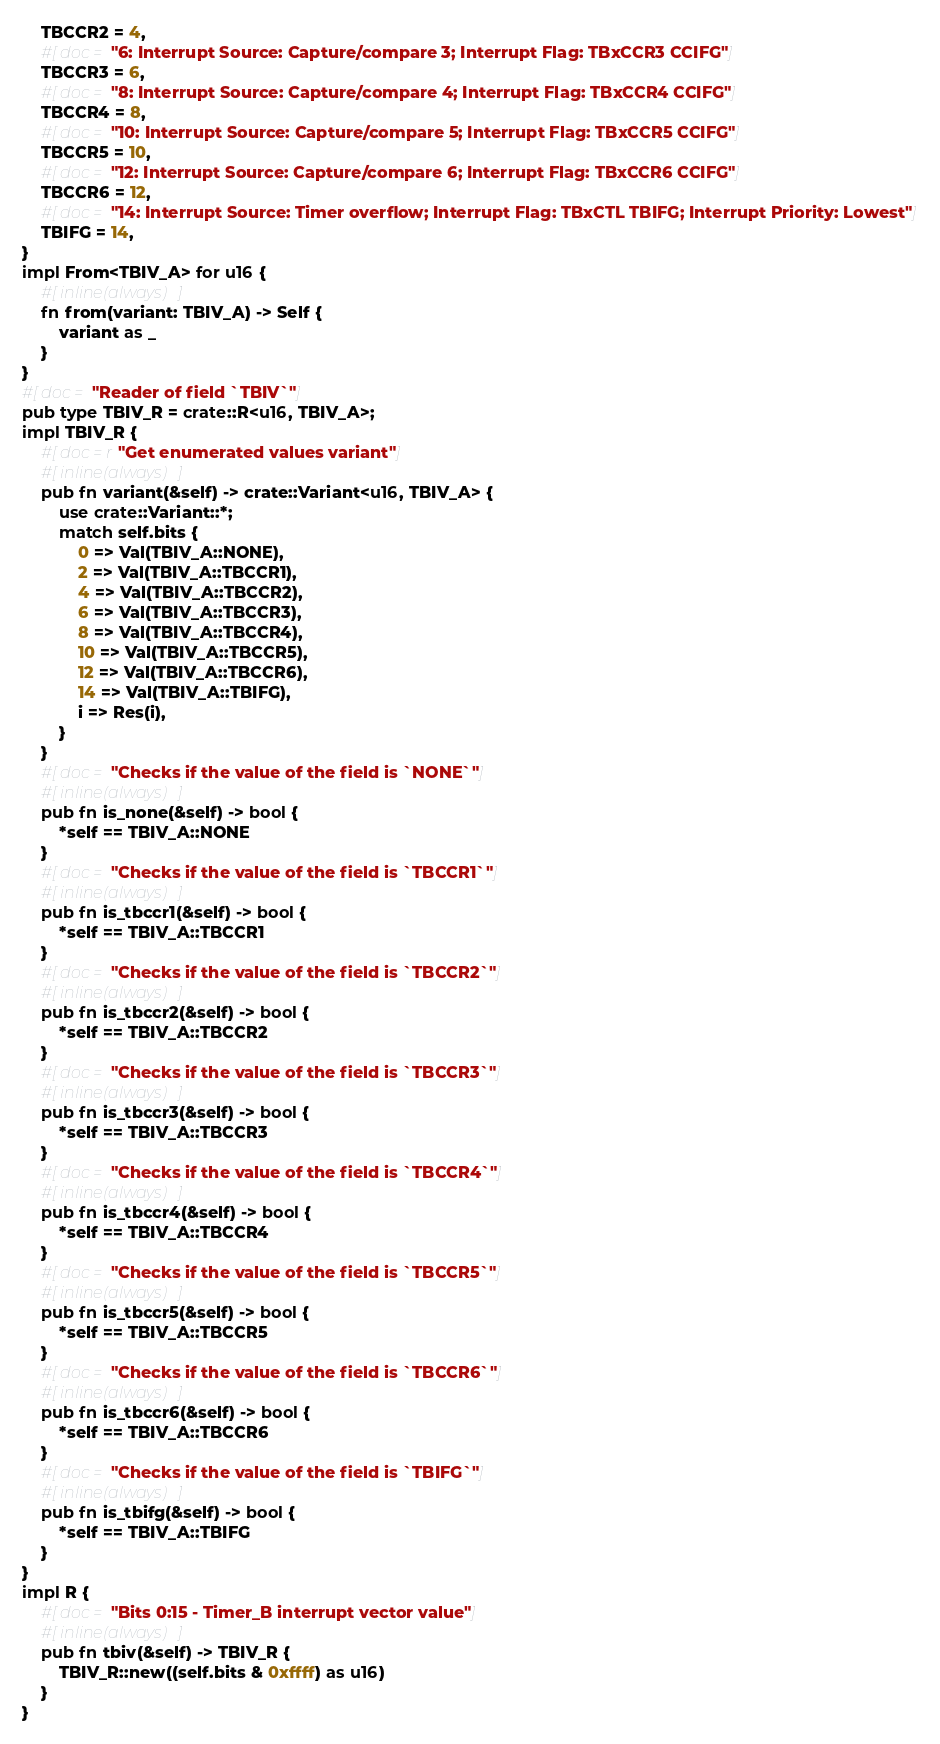Convert code to text. <code><loc_0><loc_0><loc_500><loc_500><_Rust_>    TBCCR2 = 4,
    #[doc = "6: Interrupt Source: Capture/compare 3; Interrupt Flag: TBxCCR3 CCIFG"]
    TBCCR3 = 6,
    #[doc = "8: Interrupt Source: Capture/compare 4; Interrupt Flag: TBxCCR4 CCIFG"]
    TBCCR4 = 8,
    #[doc = "10: Interrupt Source: Capture/compare 5; Interrupt Flag: TBxCCR5 CCIFG"]
    TBCCR5 = 10,
    #[doc = "12: Interrupt Source: Capture/compare 6; Interrupt Flag: TBxCCR6 CCIFG"]
    TBCCR6 = 12,
    #[doc = "14: Interrupt Source: Timer overflow; Interrupt Flag: TBxCTL TBIFG; Interrupt Priority: Lowest"]
    TBIFG = 14,
}
impl From<TBIV_A> for u16 {
    #[inline(always)]
    fn from(variant: TBIV_A) -> Self {
        variant as _
    }
}
#[doc = "Reader of field `TBIV`"]
pub type TBIV_R = crate::R<u16, TBIV_A>;
impl TBIV_R {
    #[doc = r"Get enumerated values variant"]
    #[inline(always)]
    pub fn variant(&self) -> crate::Variant<u16, TBIV_A> {
        use crate::Variant::*;
        match self.bits {
            0 => Val(TBIV_A::NONE),
            2 => Val(TBIV_A::TBCCR1),
            4 => Val(TBIV_A::TBCCR2),
            6 => Val(TBIV_A::TBCCR3),
            8 => Val(TBIV_A::TBCCR4),
            10 => Val(TBIV_A::TBCCR5),
            12 => Val(TBIV_A::TBCCR6),
            14 => Val(TBIV_A::TBIFG),
            i => Res(i),
        }
    }
    #[doc = "Checks if the value of the field is `NONE`"]
    #[inline(always)]
    pub fn is_none(&self) -> bool {
        *self == TBIV_A::NONE
    }
    #[doc = "Checks if the value of the field is `TBCCR1`"]
    #[inline(always)]
    pub fn is_tbccr1(&self) -> bool {
        *self == TBIV_A::TBCCR1
    }
    #[doc = "Checks if the value of the field is `TBCCR2`"]
    #[inline(always)]
    pub fn is_tbccr2(&self) -> bool {
        *self == TBIV_A::TBCCR2
    }
    #[doc = "Checks if the value of the field is `TBCCR3`"]
    #[inline(always)]
    pub fn is_tbccr3(&self) -> bool {
        *self == TBIV_A::TBCCR3
    }
    #[doc = "Checks if the value of the field is `TBCCR4`"]
    #[inline(always)]
    pub fn is_tbccr4(&self) -> bool {
        *self == TBIV_A::TBCCR4
    }
    #[doc = "Checks if the value of the field is `TBCCR5`"]
    #[inline(always)]
    pub fn is_tbccr5(&self) -> bool {
        *self == TBIV_A::TBCCR5
    }
    #[doc = "Checks if the value of the field is `TBCCR6`"]
    #[inline(always)]
    pub fn is_tbccr6(&self) -> bool {
        *self == TBIV_A::TBCCR6
    }
    #[doc = "Checks if the value of the field is `TBIFG`"]
    #[inline(always)]
    pub fn is_tbifg(&self) -> bool {
        *self == TBIV_A::TBIFG
    }
}
impl R {
    #[doc = "Bits 0:15 - Timer_B interrupt vector value"]
    #[inline(always)]
    pub fn tbiv(&self) -> TBIV_R {
        TBIV_R::new((self.bits & 0xffff) as u16)
    }
}
</code> 